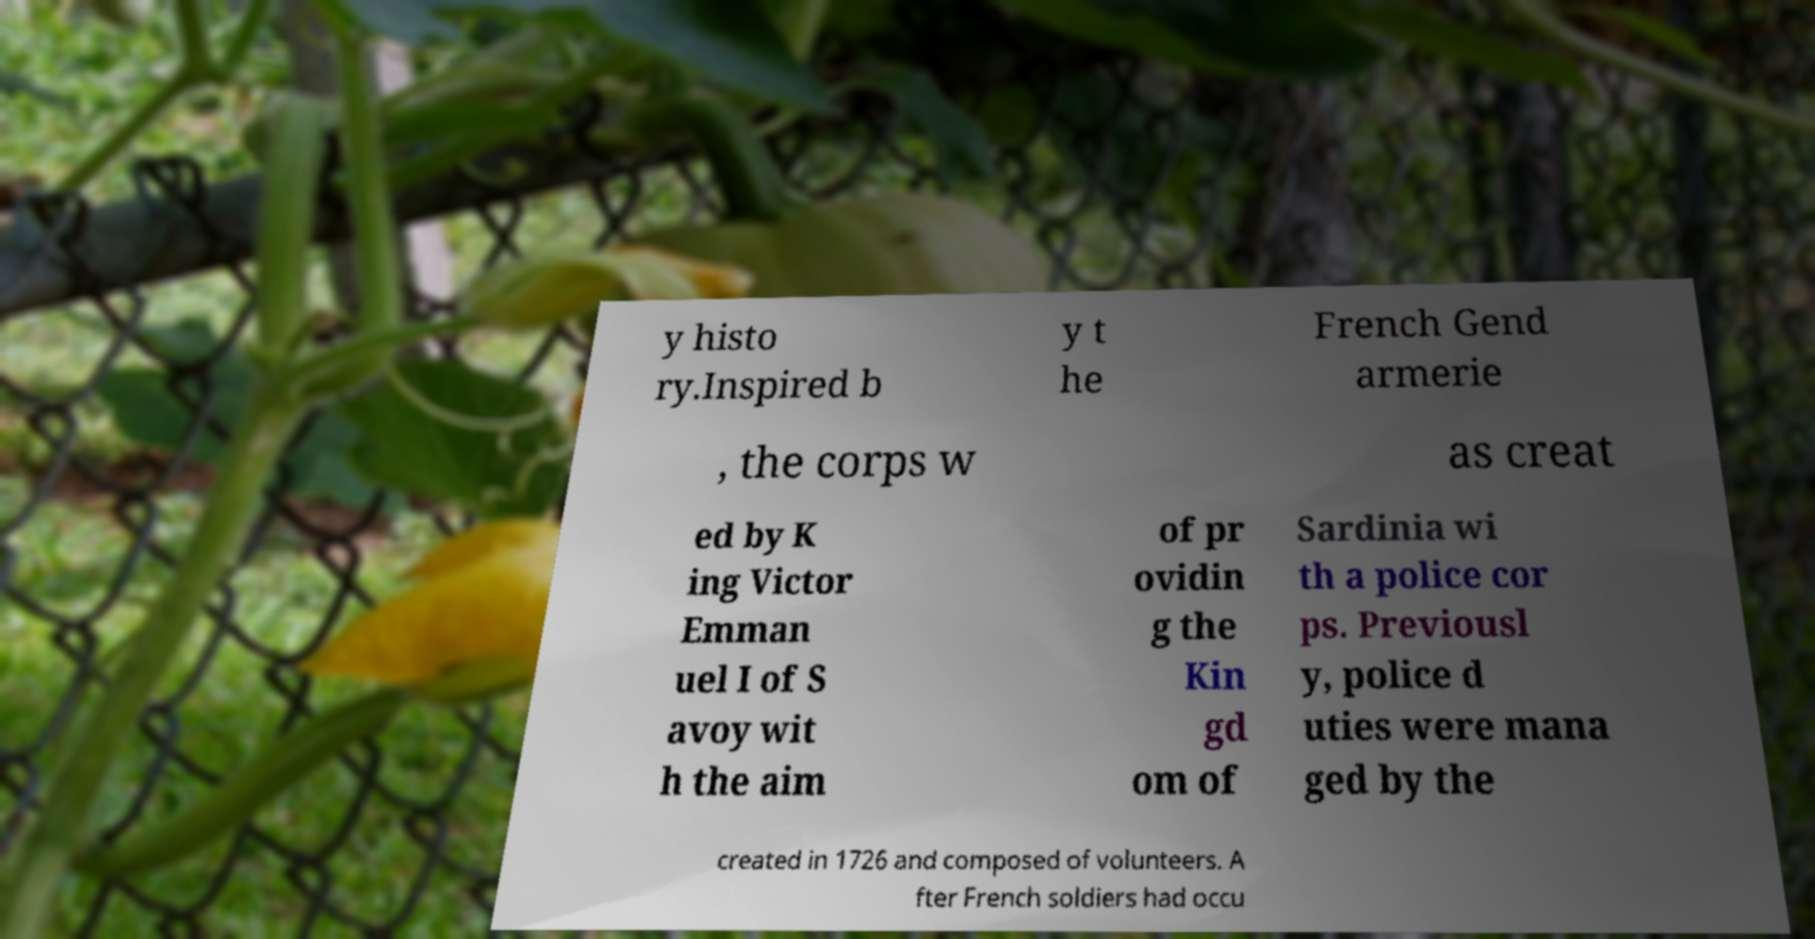There's text embedded in this image that I need extracted. Can you transcribe it verbatim? y histo ry.Inspired b y t he French Gend armerie , the corps w as creat ed by K ing Victor Emman uel I of S avoy wit h the aim of pr ovidin g the Kin gd om of Sardinia wi th a police cor ps. Previousl y, police d uties were mana ged by the created in 1726 and composed of volunteers. A fter French soldiers had occu 